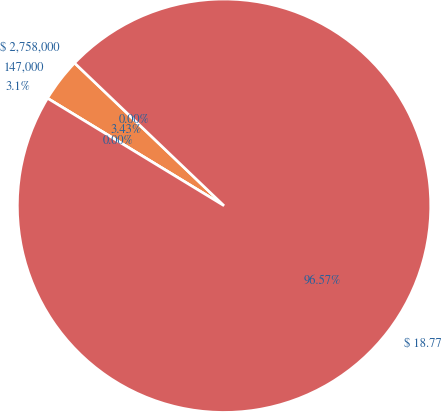Convert chart to OTSL. <chart><loc_0><loc_0><loc_500><loc_500><pie_chart><fcel>$ 2,758,000<fcel>147,000<fcel>3.1%<fcel>$ 18.77<nl><fcel>0.0%<fcel>3.43%<fcel>0.0%<fcel>96.57%<nl></chart> 